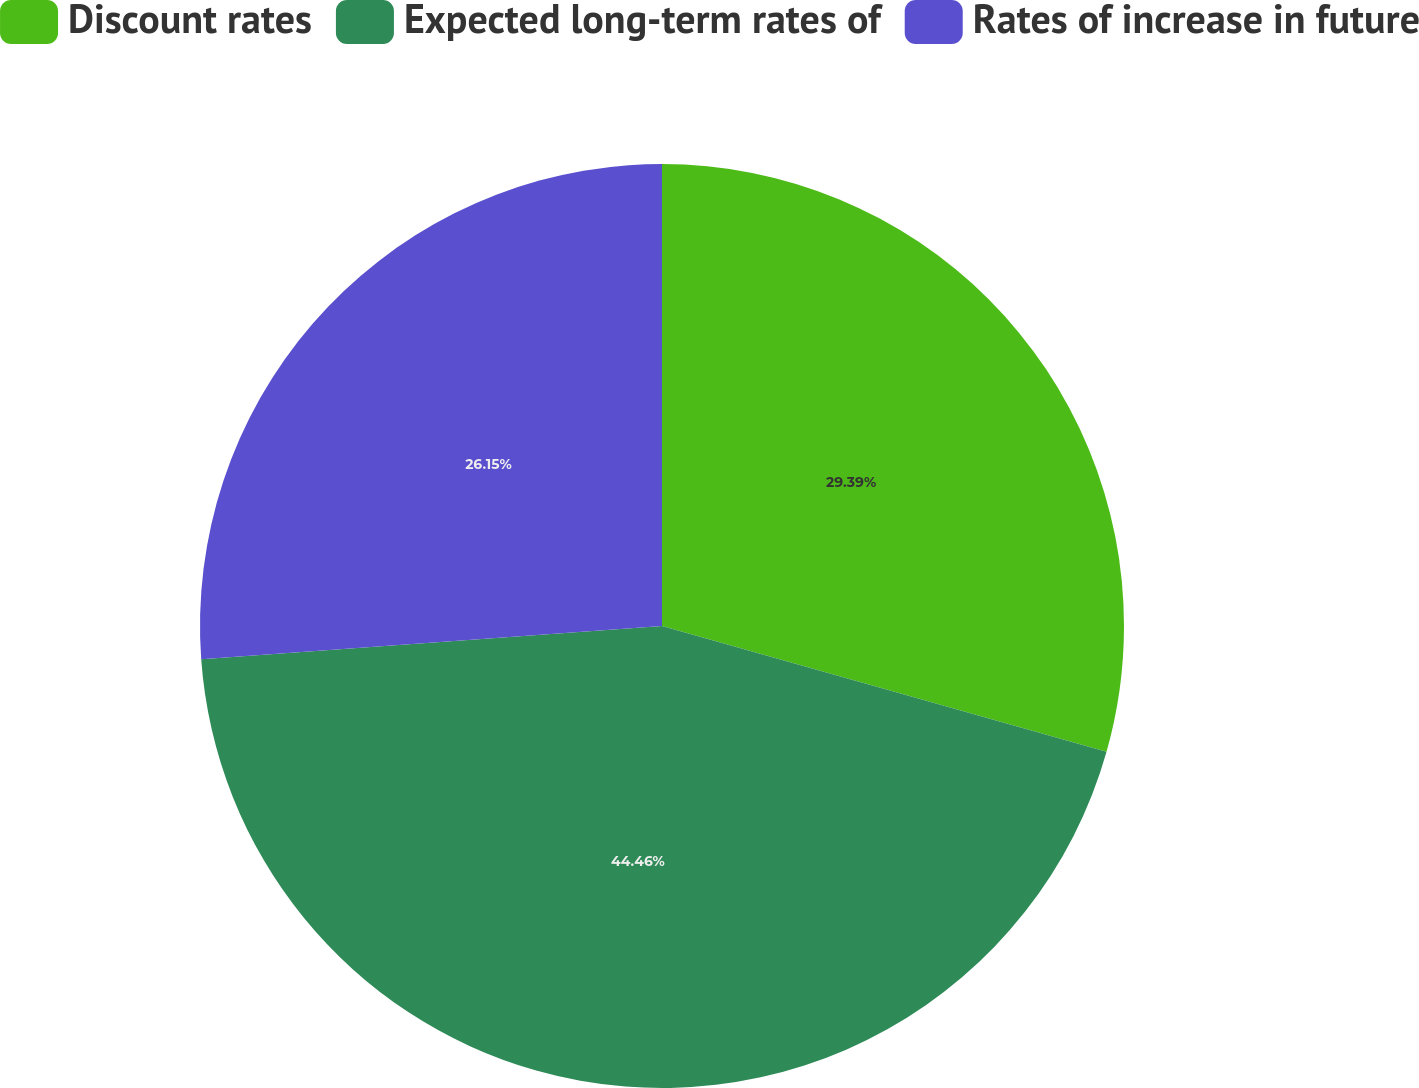Convert chart. <chart><loc_0><loc_0><loc_500><loc_500><pie_chart><fcel>Discount rates<fcel>Expected long-term rates of<fcel>Rates of increase in future<nl><fcel>29.39%<fcel>44.46%<fcel>26.15%<nl></chart> 